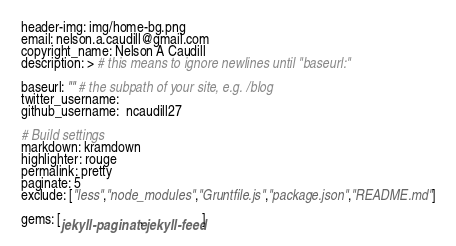<code> <loc_0><loc_0><loc_500><loc_500><_YAML_>header-img: img/home-bg.png
email: nelson.a.caudill@gmail.com
copyright_name: Nelson A Caudill
description: > # this means to ignore newlines until "baseurl:"
  
baseurl: "" # the subpath of your site, e.g. /blog
twitter_username: 
github_username:  ncaudill27

# Build settings
markdown: kramdown
highlighter: rouge
permalink: pretty
paginate: 5
exclude: ["less","node_modules","Gruntfile.js","package.json","README.md"]

gems: [jekyll-paginate, jekyll-feed]
</code> 